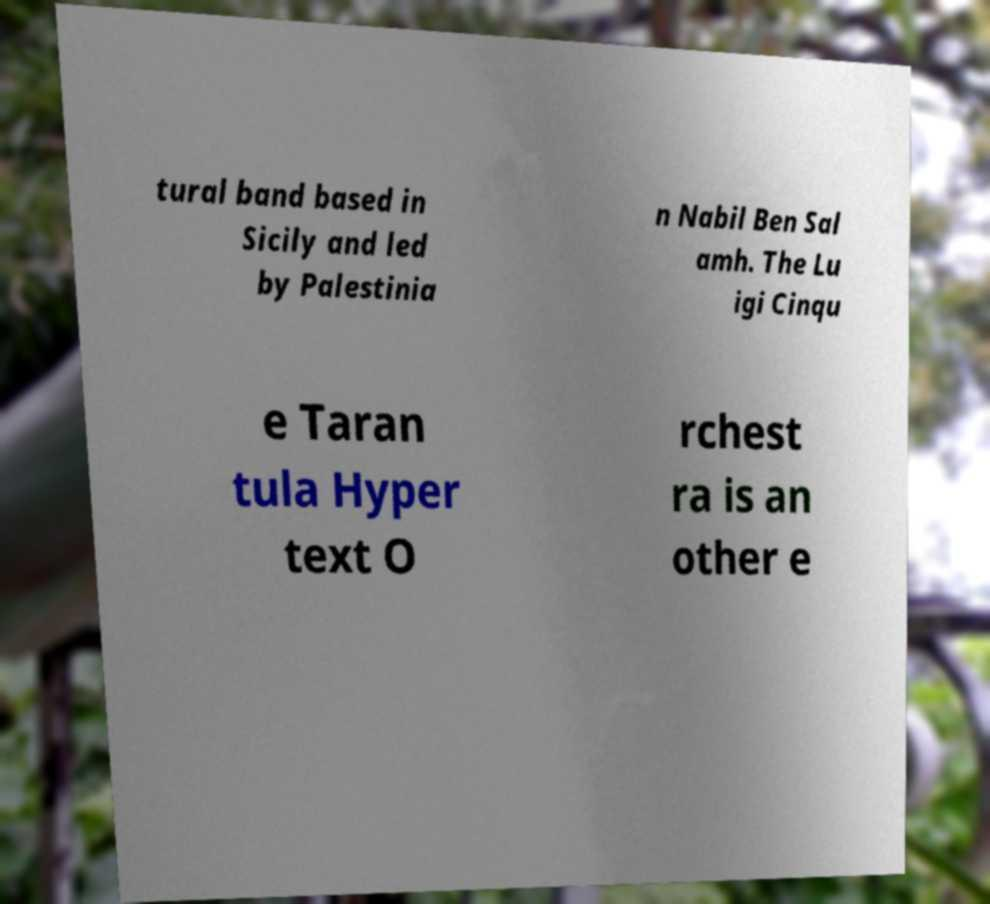Can you read and provide the text displayed in the image?This photo seems to have some interesting text. Can you extract and type it out for me? tural band based in Sicily and led by Palestinia n Nabil Ben Sal amh. The Lu igi Cinqu e Taran tula Hyper text O rchest ra is an other e 